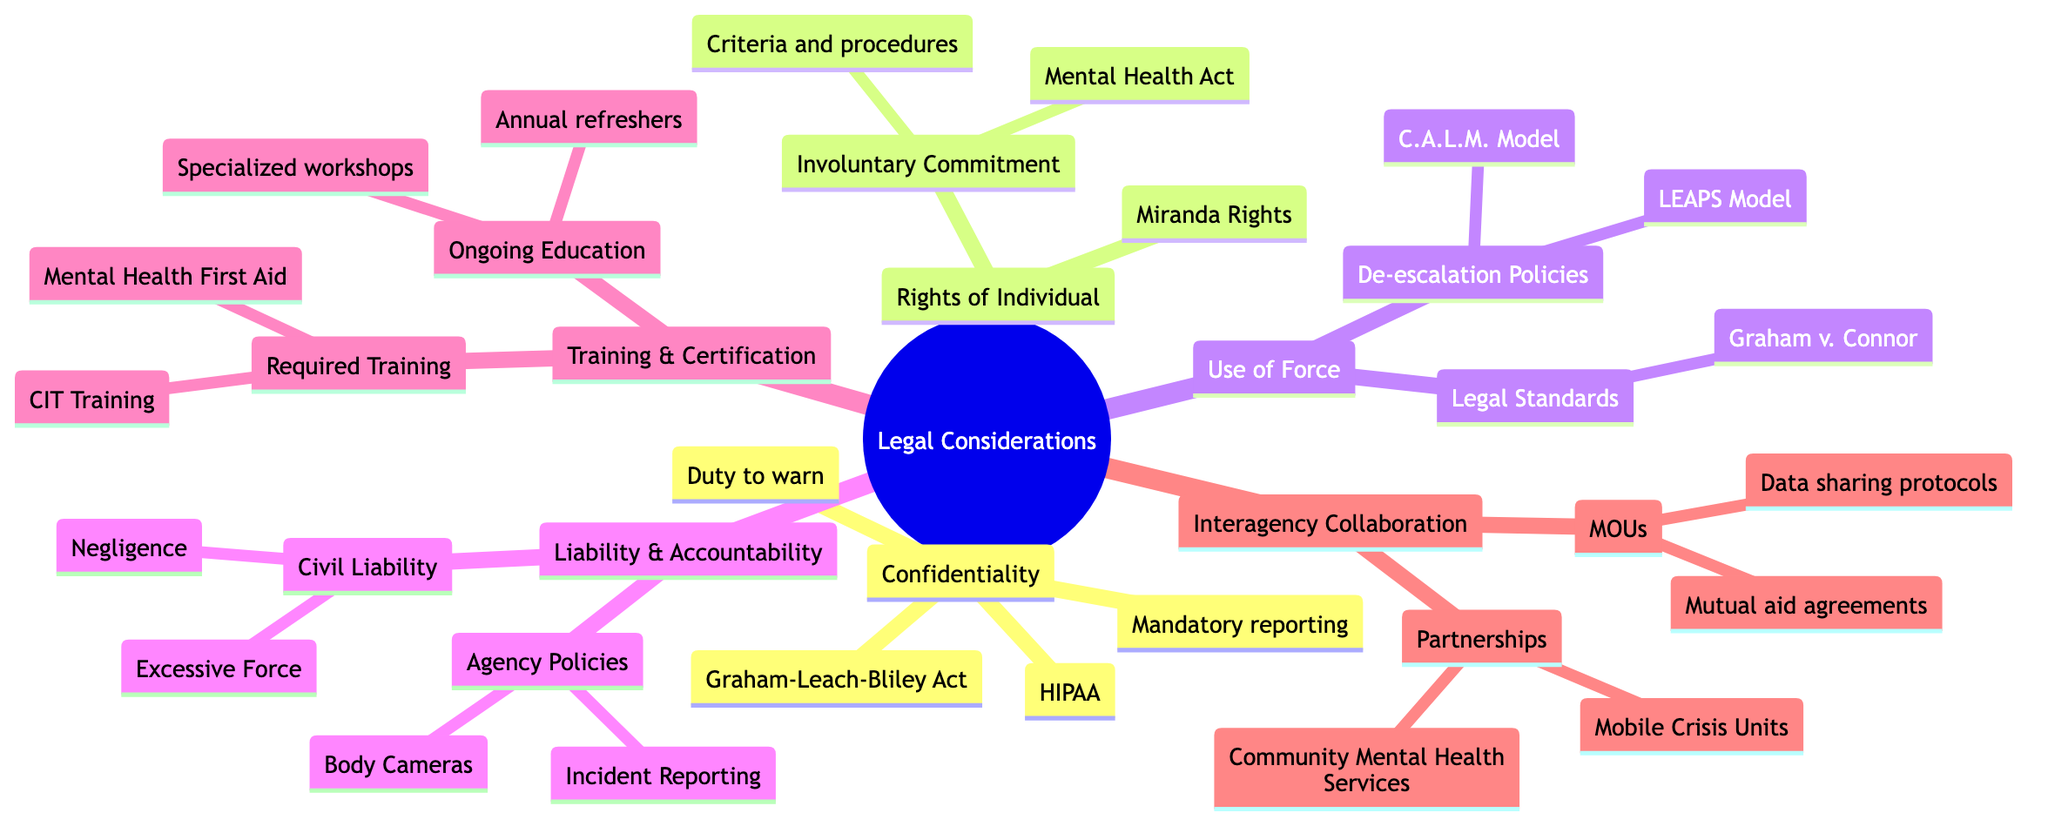What are the key laws related to confidentiality? The two key laws listed under confidentiality are HIPAA and the Graham-Leach-Bliley Act. These laws are specifically mentioned as crucial in the context of confidentiality in crisis intervention.
Answer: HIPAA, Graham-Leach-Bliley Act What does the "Rights of the Individual" section include? The section titled "Rights of the Individual" includes Miranda Rights and Involuntary Commitment, which are the main topics presented there.
Answer: Miranda Rights, Involuntary Commitment Which model is mentioned under de-escalation policies? The C.A.L.M. Model and the LEAPS Model are both identified under the de-escalation policies in the diagram, indicating approaches used to de-escalate crisis situations.
Answer: C.A.L.M. Model, LEAPS Model How many types of liability are listed? There are two types of civil liability listed: Negligence and Excessive Force. This indicates the legal issues law enforcement may face during crisis intervention.
Answer: 2 What type of training is required? The required training includes CIT Training and Mental Health First Aid, highlighting essential training programs for crisis intervention.
Answer: CIT Training, Mental Health First Aid How are interagency collaboration partnerships categorized? The partnerships in the interagency collaboration section are categorized into Mobile Crisis Units and Community Mental Health Services, illustrating the collaboration necessary for effective crisis intervention.
Answer: Mobile Crisis Units, Community Mental Health Services What is essential for agency policies related to liability? Agency policies concerning liability include Body Cameras and Incident Reporting, which are crucial for accountability and legal protection in crisis situations.
Answer: Body Cameras, Incident Reporting What is the purpose of memorandums of understanding in interagency collaboration? The memorandums of understanding serve to establish mutual aid agreements and data-sharing protocols, facilitating cooperation between agencies during crises.
Answer: Mutual aid agreements, Data sharing protocols What is the main focus of the Training and Certification section? The section on Training and Certification focuses on Required Training and Ongoing Education, indicating a commitment to continuous improvement and skill development in crisis intervention.
Answer: Required Training, Ongoing Education 